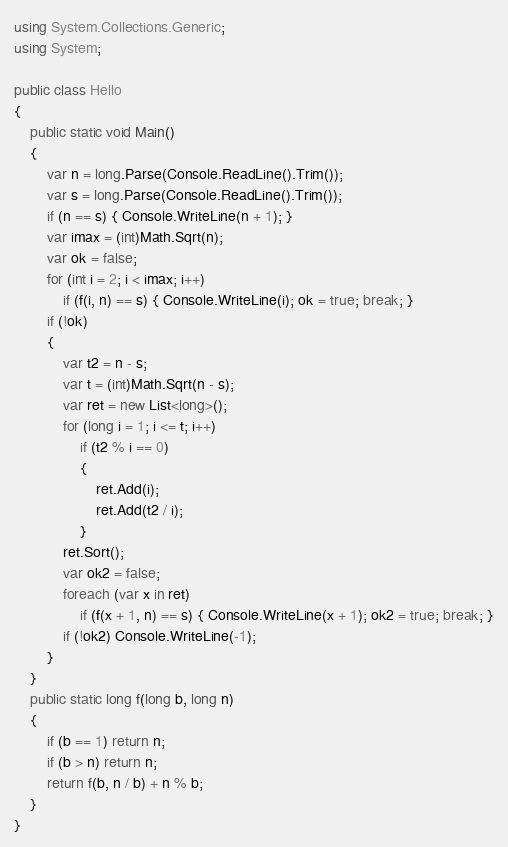<code> <loc_0><loc_0><loc_500><loc_500><_C#_>using System.Collections.Generic;
using System;

public class Hello
{
    public static void Main()
    {
        var n = long.Parse(Console.ReadLine().Trim());
        var s = long.Parse(Console.ReadLine().Trim());
        if (n == s) { Console.WriteLine(n + 1); }
        var imax = (int)Math.Sqrt(n);
        var ok = false;
        for (int i = 2; i < imax; i++)
            if (f(i, n) == s) { Console.WriteLine(i); ok = true; break; }
        if (!ok)
        {
            var t2 = n - s;
            var t = (int)Math.Sqrt(n - s);
            var ret = new List<long>();
            for (long i = 1; i <= t; i++)
                if (t2 % i == 0)
                {
                    ret.Add(i);
                    ret.Add(t2 / i);
                }
            ret.Sort();
            var ok2 = false;
            foreach (var x in ret)
                if (f(x + 1, n) == s) { Console.WriteLine(x + 1); ok2 = true; break; }
            if (!ok2) Console.WriteLine(-1);
        }
    }
    public static long f(long b, long n)
    {
        if (b == 1) return n;
        if (b > n) return n;
        return f(b, n / b) + n % b;
    }
}

</code> 